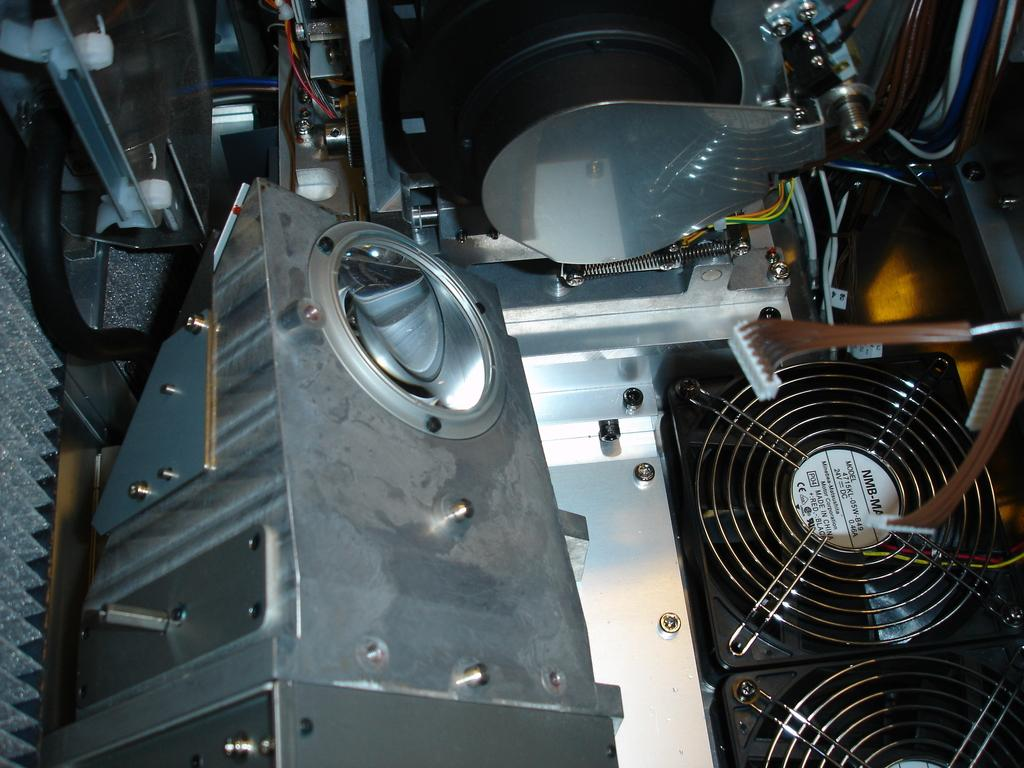What type of object is the main subject in the image? There is an electronic machine in the image. Can you describe the electronic machine in more detail? Unfortunately, the provided facts do not offer more specific details about the electronic machine. What might be the purpose of the electronic machine in the image? Without additional information, it is difficult to determine the purpose of the electronic machine. How many stars can be seen in the image? There are no stars present in the image, as it features an electronic machine. 